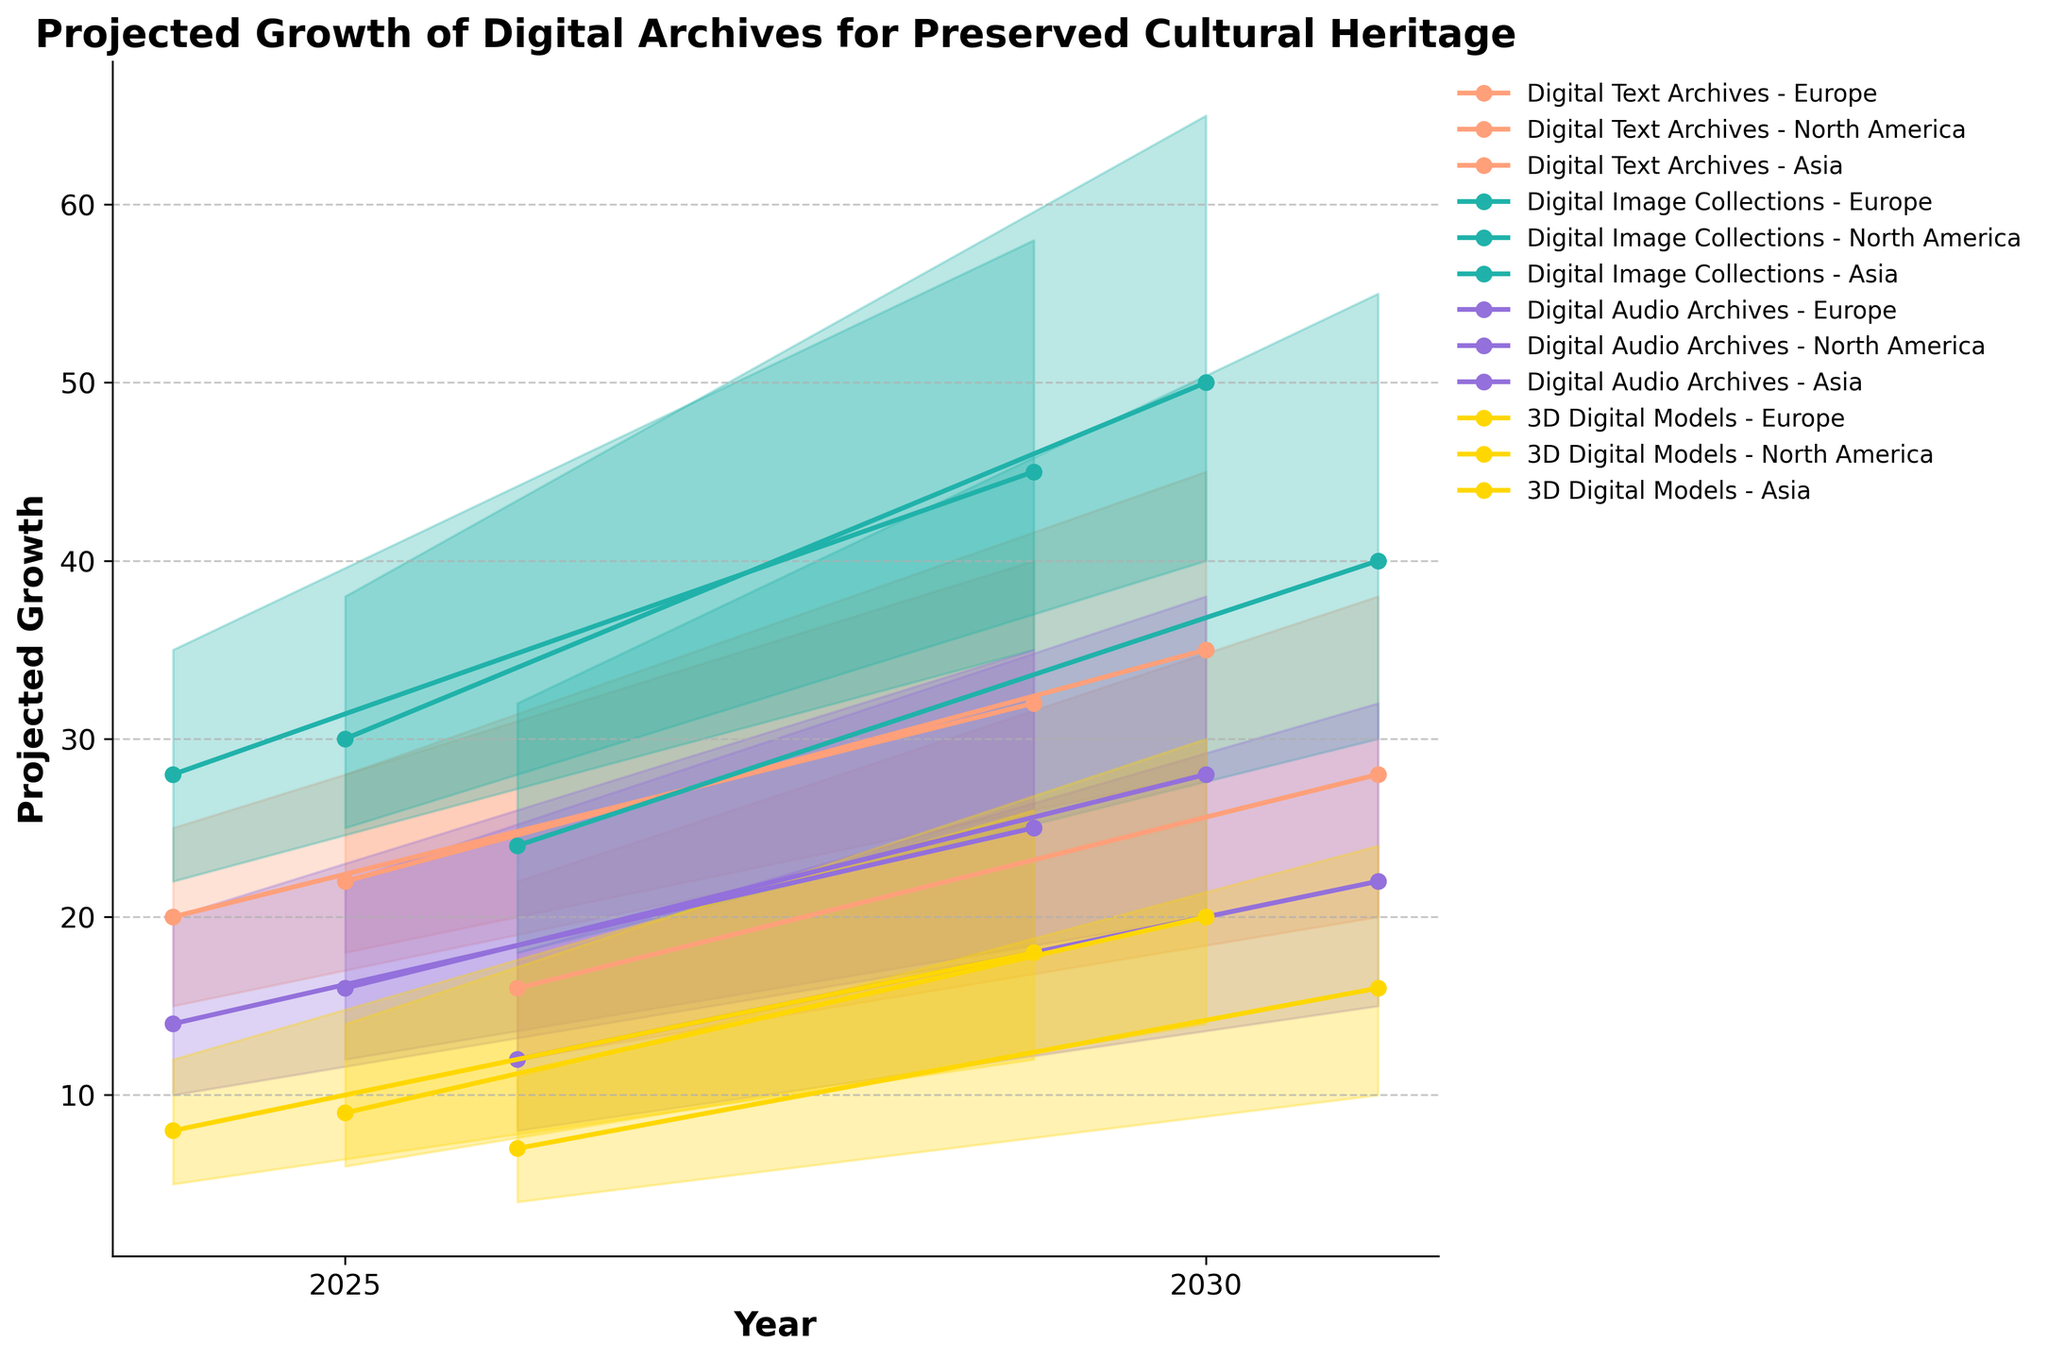What's the title of the chart? The title of the chart is usually located at the top center of the figure.
Answer: Projected Growth of Digital Archives for Preserved Cultural Heritage How many years are displayed on the x-axis? The x-axis indicates each year provided in the data. By looking at the x-axis ticks or labels, one can count the number of distinct years.
Answer: 2 What is the projected mid-range growth for Digital Audio Archives in North America by 2030? By identifying the color associated with Digital Audio Archives and matching it for North America, we can read the mid-range value from the height of the line at the year 2030 position.
Answer: 28 Which media type in Europe is projected to have the highest mid-range growth by 2030? Compare the mid-range growth values for all media types in Europe at the 2030 marker and identify the highest one.
Answer: Digital Image Collections How does the projected mid-range growth for Digital Text Archives in Asia compare between 2025 and 2030? Compare the mid-range growth values at the different years for Digital Text Archives in Asia and calculate the difference.
Answer: It increases from 16 to 28 Which region is projected to have the highest growth range for 3D Digital Models by 2030? Compare all the growth ranges (from low to high) for each region for 3D Digital Models in 2030 and identify the highest one.
Answer: North America What is the average projected mid-range growth for Digital Image Collections across all regions by 2025? Sum the mid-range values for Digital Image Collections in 2025 across all regions and divide by the number of regions.
Answer: (28 + 30 + 24) / 3 = 27.33 How does the variation in projected growth for Digital Text Archives in North America compare between 2025 and 2030? Calculate the range (high - low) for each year and compare them. The range for 2025 is (28-18) and for 2030 is (45-28).
Answer: 10 for 2025 and 17 for 2030 Which media type shows the least variation in mid-range growth between 2025 and 2030 in Europe? Evaluate the difference in mid-range growth between 2025 and 2030 for each media type in Europe and identify the smallest difference.
Answer: 3D Digital Models (8 to 18) 